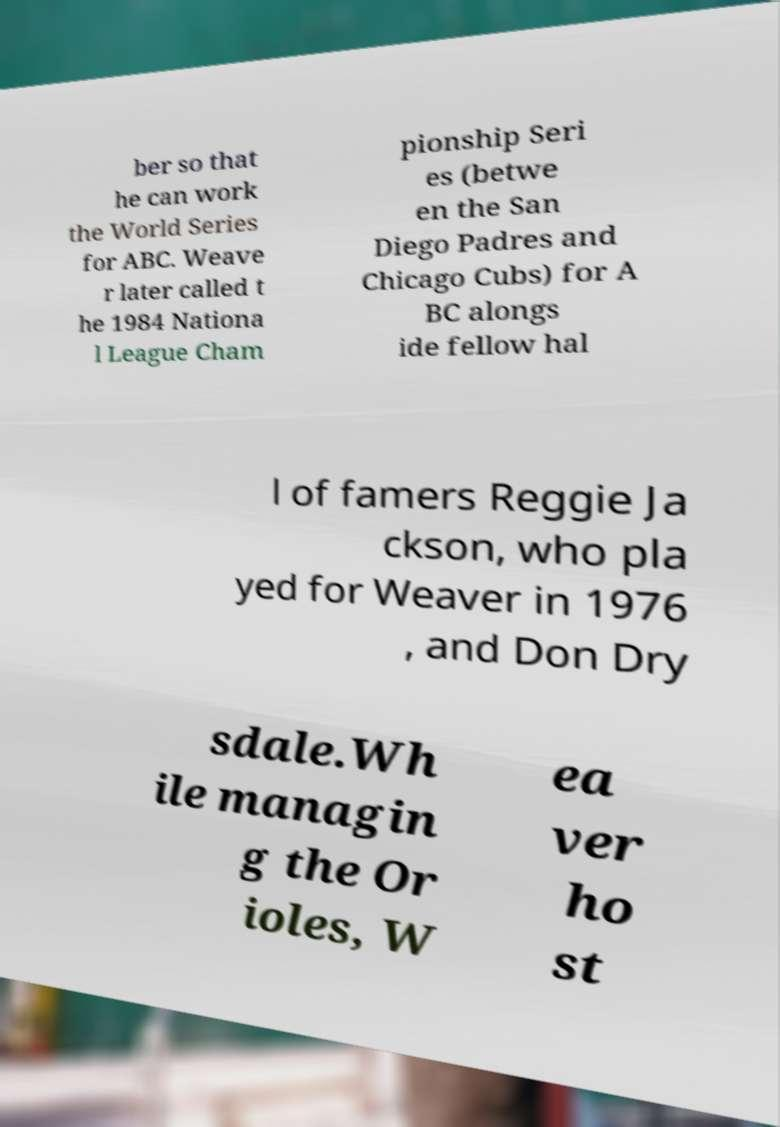For documentation purposes, I need the text within this image transcribed. Could you provide that? ber so that he can work the World Series for ABC. Weave r later called t he 1984 Nationa l League Cham pionship Seri es (betwe en the San Diego Padres and Chicago Cubs) for A BC alongs ide fellow hal l of famers Reggie Ja ckson, who pla yed for Weaver in 1976 , and Don Dry sdale.Wh ile managin g the Or ioles, W ea ver ho st 